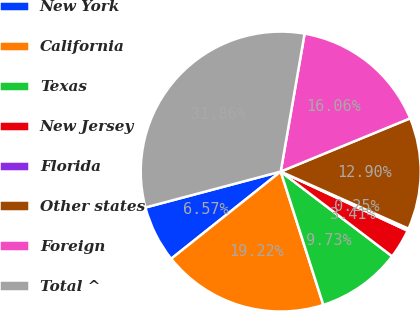Convert chart to OTSL. <chart><loc_0><loc_0><loc_500><loc_500><pie_chart><fcel>New York<fcel>California<fcel>Texas<fcel>New Jersey<fcel>Florida<fcel>Other states<fcel>Foreign<fcel>Total ^<nl><fcel>6.57%<fcel>19.22%<fcel>9.73%<fcel>3.41%<fcel>0.25%<fcel>12.9%<fcel>16.06%<fcel>31.86%<nl></chart> 